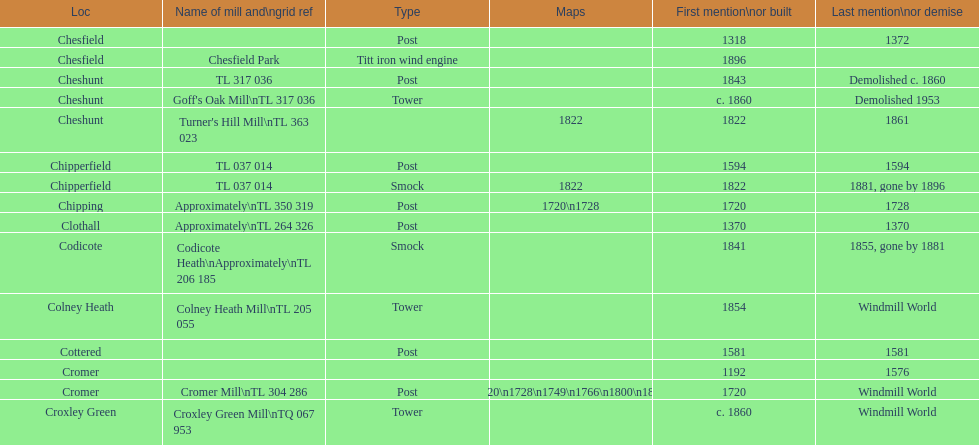What is the number of locations without any photographs? 14. 